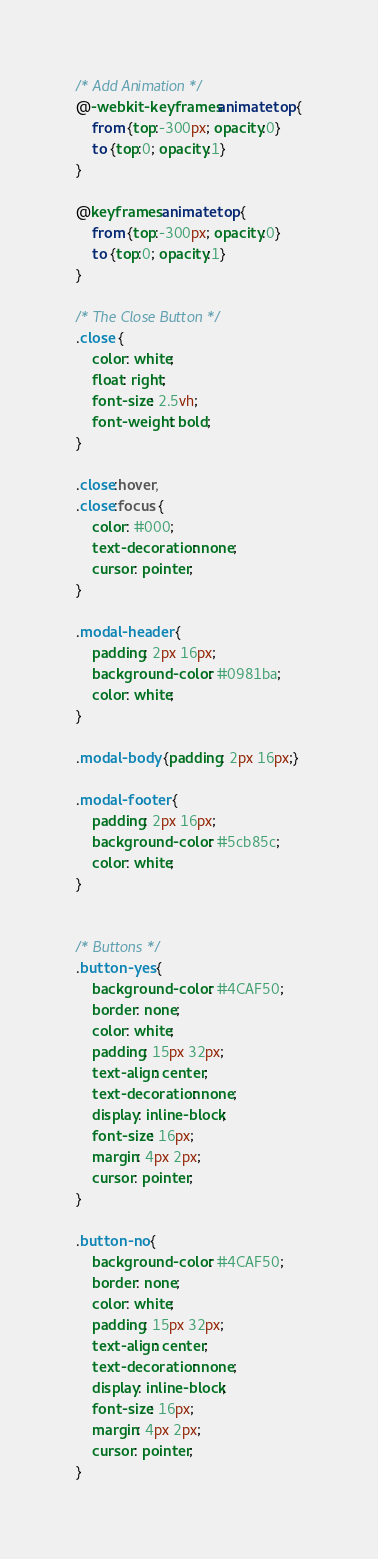<code> <loc_0><loc_0><loc_500><loc_500><_CSS_>
/* Add Animation */
@-webkit-keyframes animatetop {
    from {top:-300px; opacity:0} 
    to {top:0; opacity:1}
}

@keyframes animatetop {
    from {top:-300px; opacity:0}
    to {top:0; opacity:1}
}

/* The Close Button */
.close {
    color: white;
    float: right;
    font-size: 2.5vh;
    font-weight: bold;
}

.close:hover,
.close:focus {
    color: #000;
    text-decoration: none;
    cursor: pointer;
}

.modal-header {
    padding: 2px 16px;
    background-color: #0981ba;
    color: white;
}

.modal-body {padding: 2px 16px;}

.modal-footer {
    padding: 2px 16px;
    background-color: #5cb85c;
    color: white;
}


/* Buttons */
.button-yes {
    background-color: #4CAF50;
    border: none;
    color: white;
    padding: 15px 32px;
    text-align: center;
    text-decoration: none;
    display: inline-block;
    font-size: 16px;
    margin: 4px 2px;
    cursor: pointer;
}

.button-no {
    background-color: #4CAF50;
    border: none;
    color: white;
    padding: 15px 32px;
    text-align: center;
    text-decoration: none;
    display: inline-block;
    font-size: 16px;
    margin: 4px 2px;
    cursor: pointer;
}</code> 